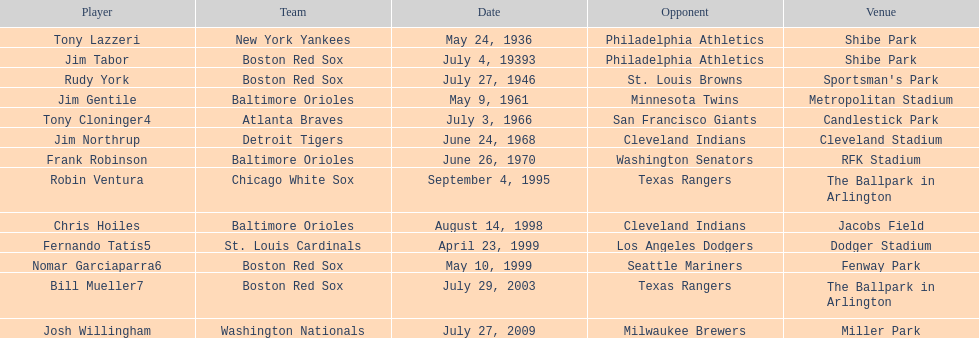When did the detroit tigers and the cleveland indians have a match? June 24, 1968. 